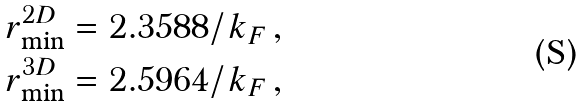<formula> <loc_0><loc_0><loc_500><loc_500>r _ { \min } ^ { 2 D } & = 2 . 3 5 8 8 / k _ { F } \, , \\ r _ { \min } ^ { 3 D } & = 2 . 5 9 6 4 / k _ { F } \, ,</formula> 